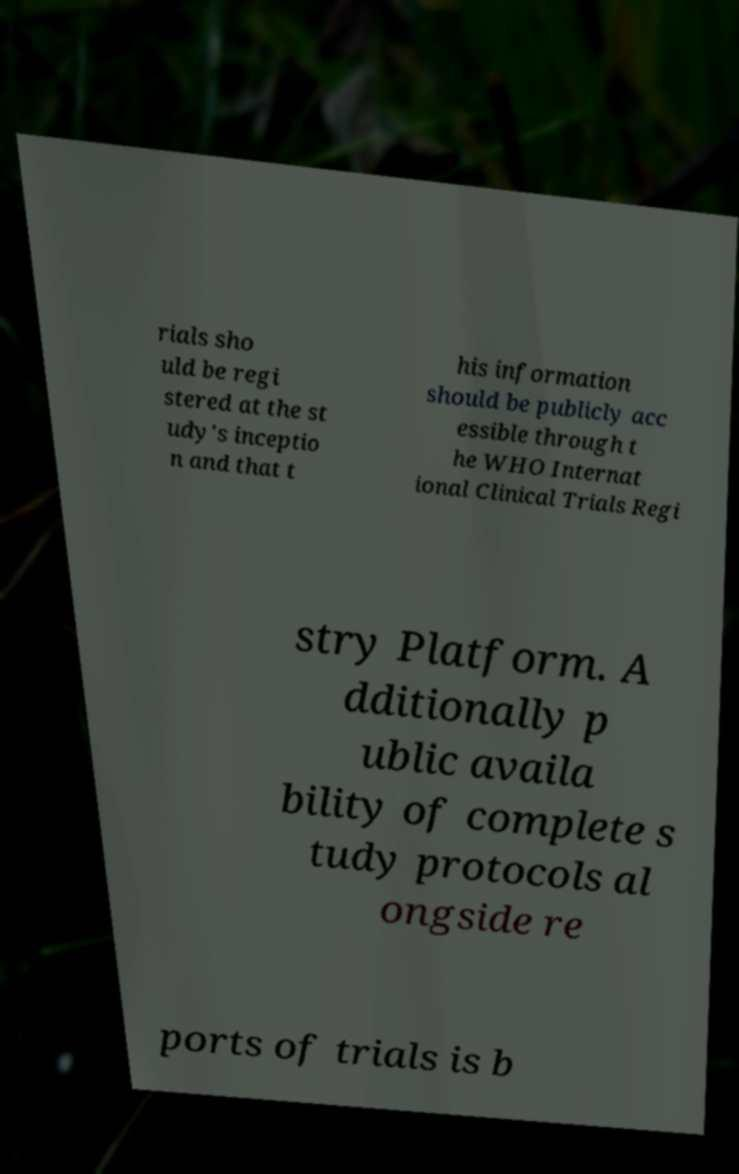For documentation purposes, I need the text within this image transcribed. Could you provide that? rials sho uld be regi stered at the st udy's inceptio n and that t his information should be publicly acc essible through t he WHO Internat ional Clinical Trials Regi stry Platform. A dditionally p ublic availa bility of complete s tudy protocols al ongside re ports of trials is b 